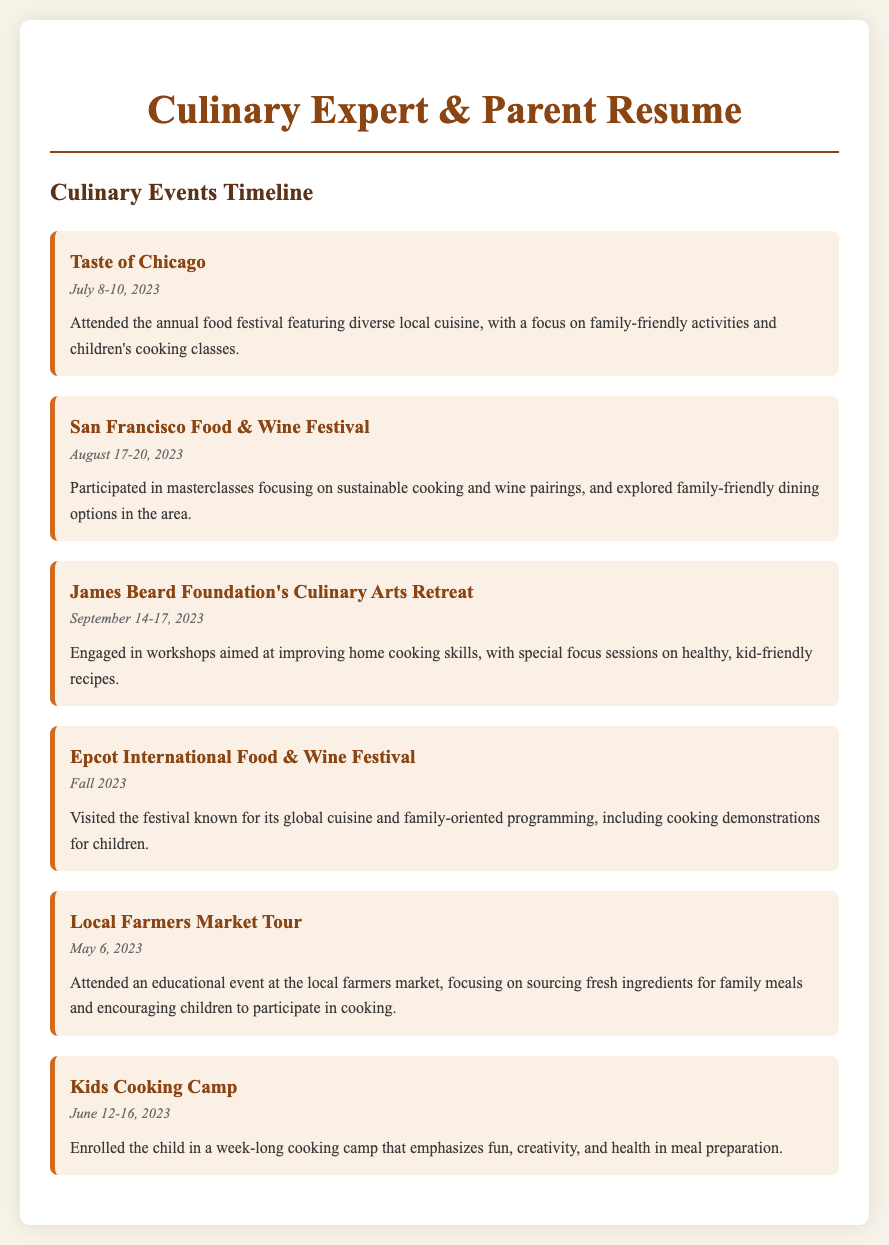What is the name of the food festival attended in July? The festival attended in July is specifically named in the document, which is "Taste of Chicago."
Answer: Taste of Chicago What date did the Kids Cooking Camp take place? The date for the Kids Cooking Camp is explicitly stated in the event description, which is June 12-16, 2023.
Answer: June 12-16, 2023 Which event focused on healthy, kid-friendly recipes? The workshop focusing on improving home cooking skills includes special focus sessions on healthy, kid-friendly recipes, as stated in the James Beard Foundation's Culinary Arts Retreat description.
Answer: James Beard Foundation's Culinary Arts Retreat What type of activities were available at the "Taste of Chicago" festival? The event description mentions that the festival featured "family-friendly activities and children's cooking classes."
Answer: Family-friendly activities and children's cooking classes In which city did the Food & Wine Festival occur? The event is specifically named "San Francisco Food & Wine Festival," indicating the city in which it was held.
Answer: San Francisco How many culinary events are listed in the timeline? By counting the events detailed in the document, we see that there are a total of six culinary events mentioned.
Answer: Six What is the main focus of the Local Farmers Market Tour? The event description emphasizes focusing on sourcing fresh ingredients for family meals and encouraging children's participation, which clearly states its main focus.
Answer: Sourcing fresh ingredients for family meals Which event is known for its global cuisine? The "Epcot International Food & Wine Festival" is recognized for its global cuisine, as noted in its description.
Answer: Epcot International Food & Wine Festival 